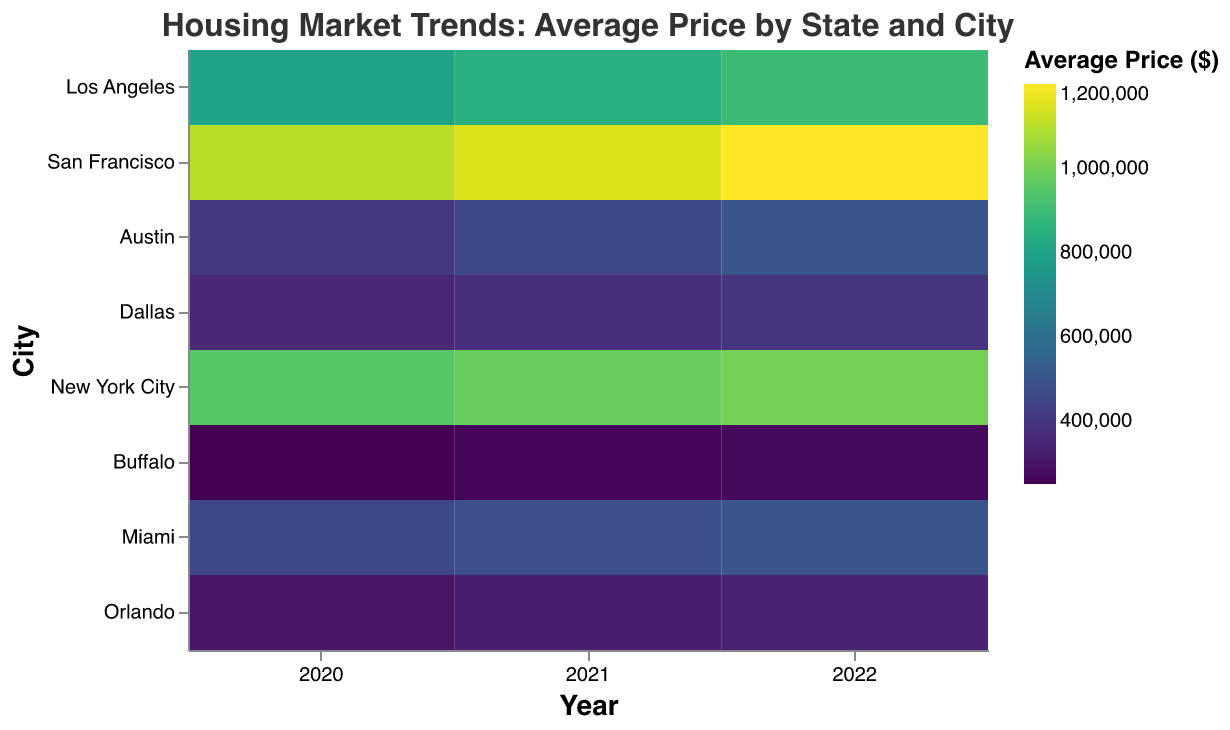How is the title of the heatmap depicted? The title is displayed at the top of the heatmap and reads "Housing Market Trends: Average Price by State and City" in Helvetica font with a font size of 16. The text color is a medium grey (#333333).
Answer: Housing Market Trends: Average Price by State and City Which city had the highest average price in 2022? San Francisco had the highest average price in 2022. The heatmap shows San Francisco with the darkest color in the 2022 column, indicating the highest price.
Answer: San Francisco What was the average price in Austin in 2021? The average price in Austin in 2021 can be found by finding Austin on the y-axis and the 2021 column on the x-axis. The corresponding cell should be checked for its tooltip information, which indicates the price. In this case, it's $450,000.
Answer: $450,000 Compare the average prices in New York City and Buffalo in 2020. Which city had a higher price? Compare the cells for New York City and Buffalo in the 2020 column. New York City's cell is darker, indicating a higher price. The specific average prices can also be checked using tooltips: $950,000 for New York City and $250,000 for Buffalo.
Answer: New York City Which city experienced the largest growth in average price from 2020 to 2022? Calculate the price increase for each city from 2020 to 2022. Los Angeles increased by $100,000, San Francisco by $100,000, Austin by $100,000, Dallas by $40,000, New York City by $50,000, Buffalo by $20,000, Miami by $50,000, and Orlando by $40,000. Austin experienced the largest growth with an increase of $100,000.
Answer: Austin What is the average price in Miami in 2020, 2021, and 2022? To find the average prices for Miami, locate the Miami row and look at the cells in the 2020, 2021, and 2022 columns. The tooltips provide the exact prices: $450,000 for 2020, $475,000 for 2021, and $500,000 for 2022.
Answer: $450,000, $475,000, & $500,000 Which state appears to have the most expensive housing, based on the cities represented? Examine the cities within each state and their corresponding colors. California's cities (Los Angeles and San Francisco) consistently have darker shades, indicating higher prices.
Answer: California What is the trend for average prices in Orlando from 2020 to 2022? To observe the trend, look at the progression of colors in the cells for Orlando from 2020 to 2022. The cells become gradually darker from 2020 ($300,000) to 2021 ($320,000) to 2022 ($340,000), indicating an increasing trend.
Answer: Increasing Which city in Texas had a higher average price in 2021? Compare the cells for Austin and Dallas in the 2021 column. Austin's cell is darker, indicating a higher price. The tooltips show $450,000 for Austin and $370,000 for Dallas.
Answer: Austin 